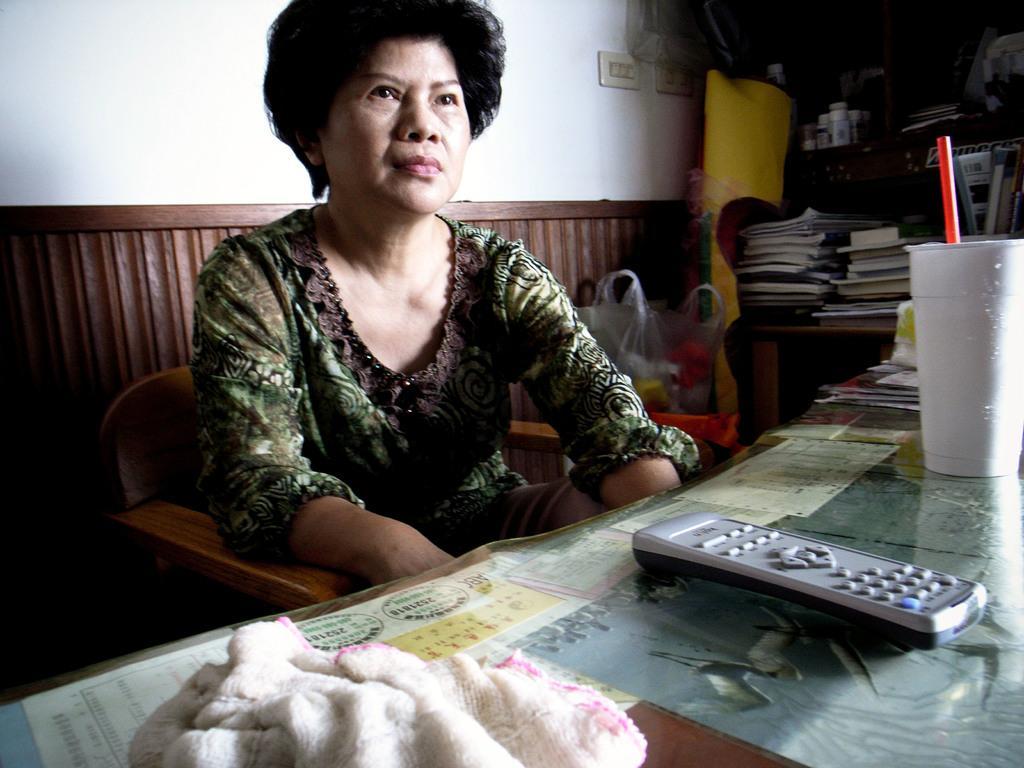Can you describe this image briefly? This image is taken indoors. In the background there is a wall and there are two switchboards. There is a wooden surface. At the bottom of the image there is a table with a napkin, a remote, a tumbler with a straw and many things on it. On the right side of the image there is a bookshelf with many books. In the middle of the image a woman is sitting on the chair and there are a few things in a cover. 